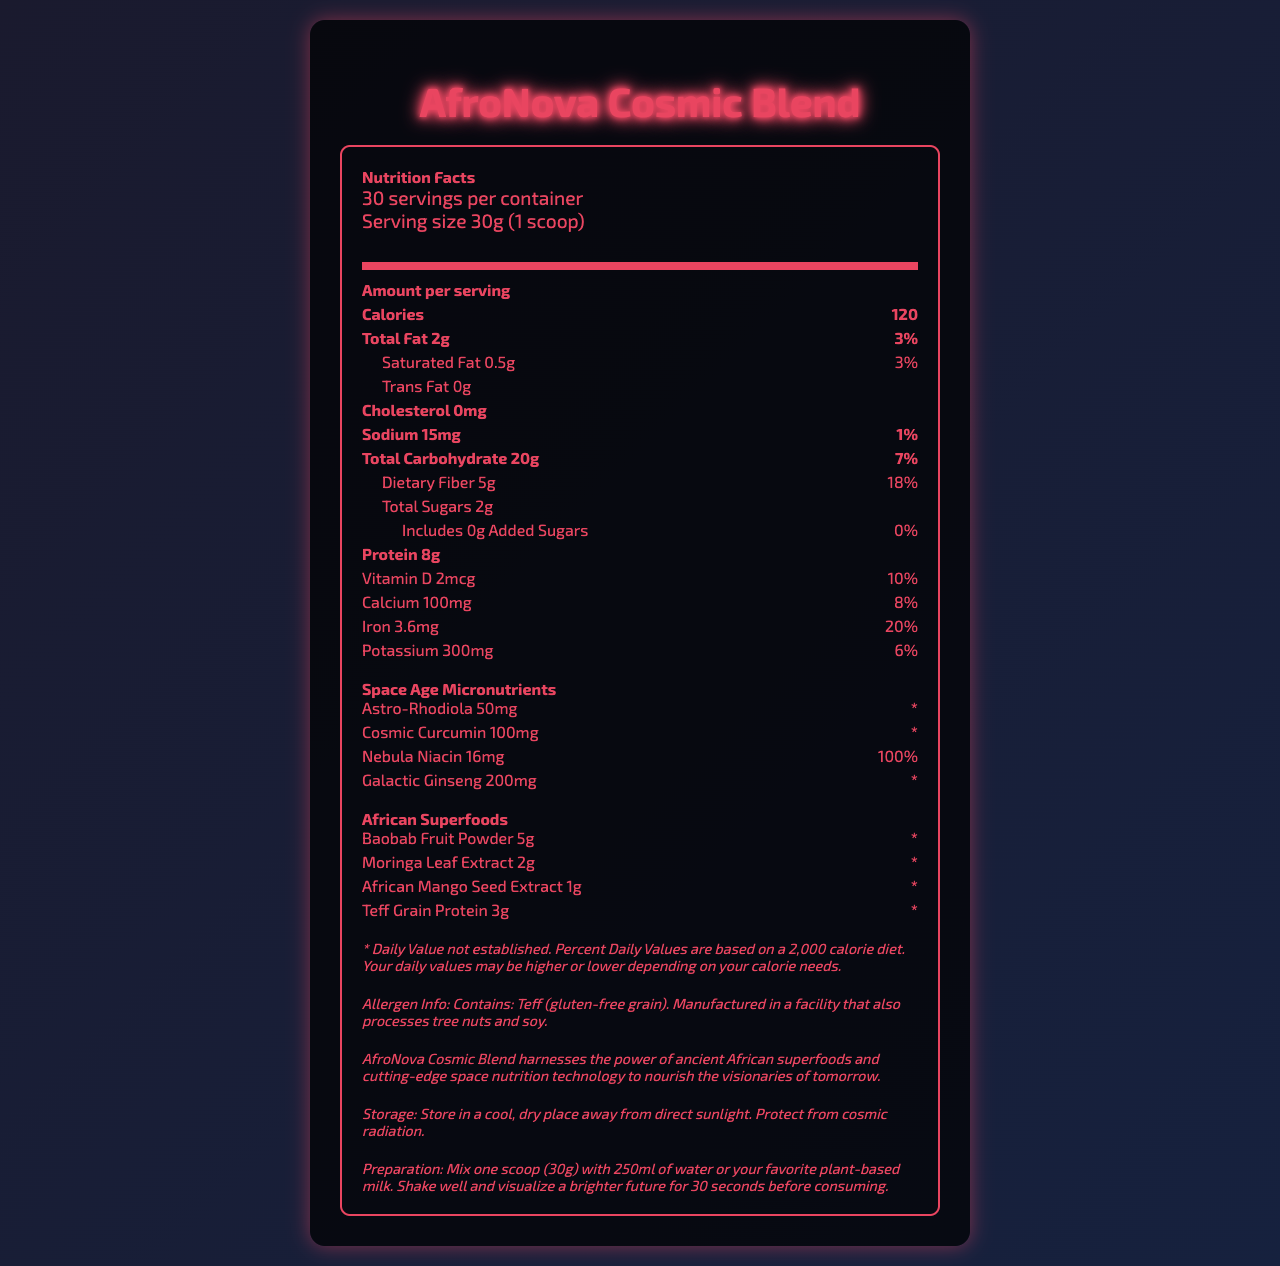what is the serving size of AfroNova Cosmic Blend? According to the document, the serving size for AfroNova Cosmic Blend is 30 grams, which is equivalent to 1 scoop.
Answer: 30g (1 scoop) how many servings are there per container? The document states there are 30 servings per container.
Answer: 30 servings how many calories are there per serving? The amount of calories per serving is specified as 120 in the document.
Answer: 120 calories how much total fat does each serving contain? Each serving contains 2 grams of total fat, as indicated in the document.
Answer: 2g how much dietary fiber is present in one serving? The document specifies that there are 5 grams of dietary fiber in one serving.
Answer: 5g what is the daily value percentage of calcium per serving? A. 8% B. 10% C. 15% D. 20% The daily value percentage of calcium per serving is 8%, as stated in the document.
Answer: A. 8% which of the following African superfoods is included in the AfroNova Cosmic Blend? I. Baobab Fruit Powder II. Moringa Leaf Extract III. Chia Seeds IV. African Mango Seed Extract The document lists Baobab Fruit Powder, Moringa Leaf Extract, and African Mango Seed Extract as included African superfoods. Chia Seeds are not mentioned.
Answer: I, II, IV does AfroNova Cosmic Blend contain any cholesterol? The document mentions that AfroNova Cosmic Blend contains 0 milligrams of cholesterol, indicating it has no cholesterol.
Answer: No how should AfroNova Cosmic Blend be stored? The storage instructions in the document say to store AfroNova Cosmic Blend in a cool, dry place away from direct sunlight and to protect it from cosmic radiation.
Answer: Store in a cool, dry place away from direct sunlight. Protect from cosmic radiation. how can one consume AfroNova Cosmic Blend? The preparation instructions in the document suggest mixing one scoop (30g) with 250ml of water or plant-based milk, shaking well, and visualizing a brighter future for 30 seconds before consumption.
Answer: Mix one scoop (30g) with 250ml of water or your favorite plant-based milk. Shake well and visualize a brighter future for 30 seconds before consuming. what is the main idea conveyed about AfroNova Cosmic Blend? The document's main idea is to emphasize the blend's combination of traditional African superfoods and modern space-age micronutrients for futuristic nourishment.
Answer: AfroNova Cosmic Blend combines the power of ancient African superfoods with futuristic space-age micronutrients to provide a nutritious supplement for those envisioning a better future. how much potassium is present per serving? Each serving contains 300 milligrams of potassium, as listed in the document.
Answer: 300mg what is the amount of added sugars per serving? The document specifies that there are zero grams of added sugars per serving.
Answer: 0g name one space-age micronutrient included in AfroNova Cosmic Blend. One space-age micronutrient included in the blend is Astro-Rhodiola, as mentioned in the document.
Answer: Astro-Rhodiola is the blend manufactured in a facility that processes soy? The allergen information in the document states that the blend is manufactured in a facility that also processes tree nuts and soy.
Answer: Yes how much Galactic Ginseng is in each serving? The document states that there are 200 milligrams of Galactic Ginseng per serving.
Answer: 200mg what is the daily value percentage of Nebula Niacin per serving? According to the document, the daily value percentage of Nebula Niacin per serving is 100%.
Answer: 100% what specific claim is made about the product's ability to protect from cosmic radiation? The document mentions to store the product away from cosmic radiation, but it does not specifically claim it protects from cosmic radiation.
Answer: Not enough information how many grams of protein are there in one serving? The document indicates that each serving contains 8 grams of protein.
Answer: 8g 